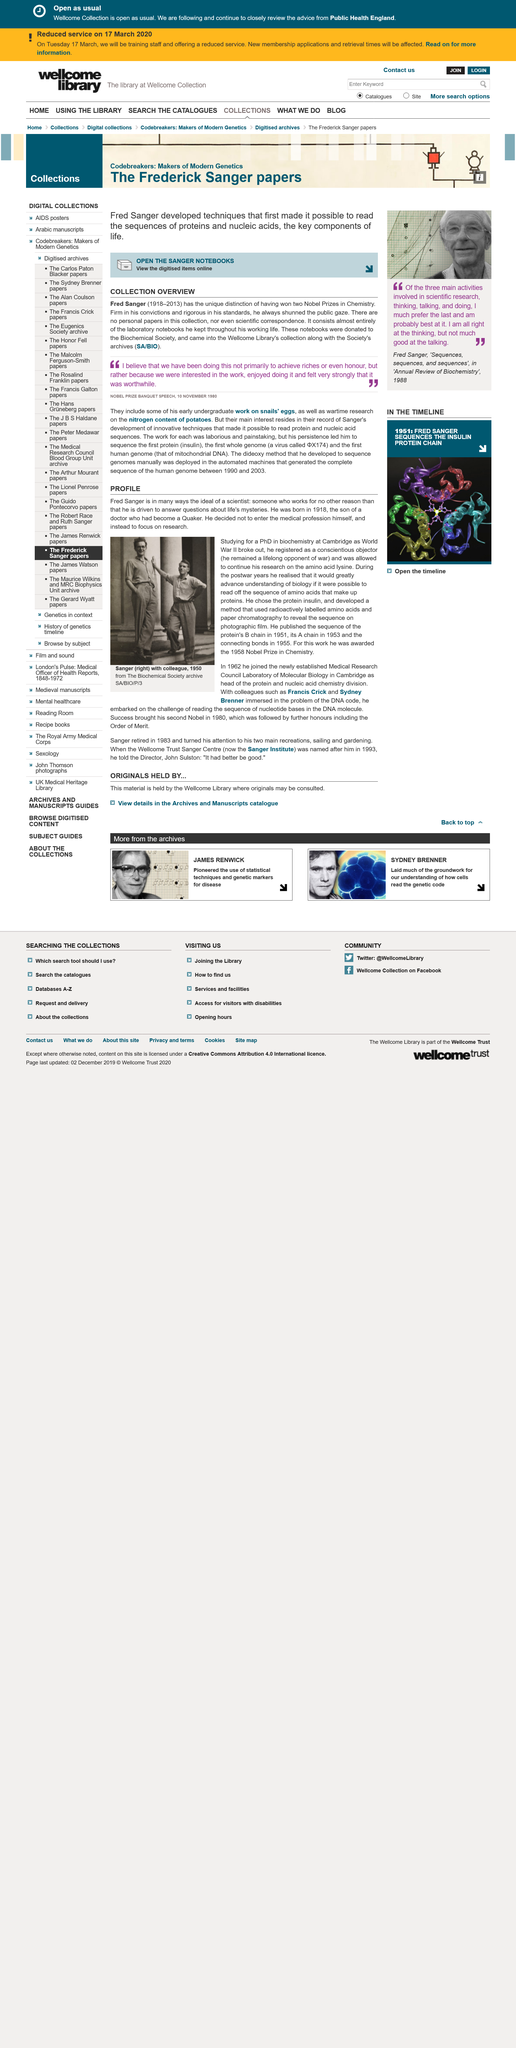Identify some key points in this picture. The key components of life are proteins and nucleic acids, which play vital roles in the function and structure of living organisms. The topic of The Frederick Sanger papers is genetics, which is a branch of science that deals with the study of heredity and the structure of genes. Fred Sanger, a chemist, won two Nobel Prizes in the field of science. 